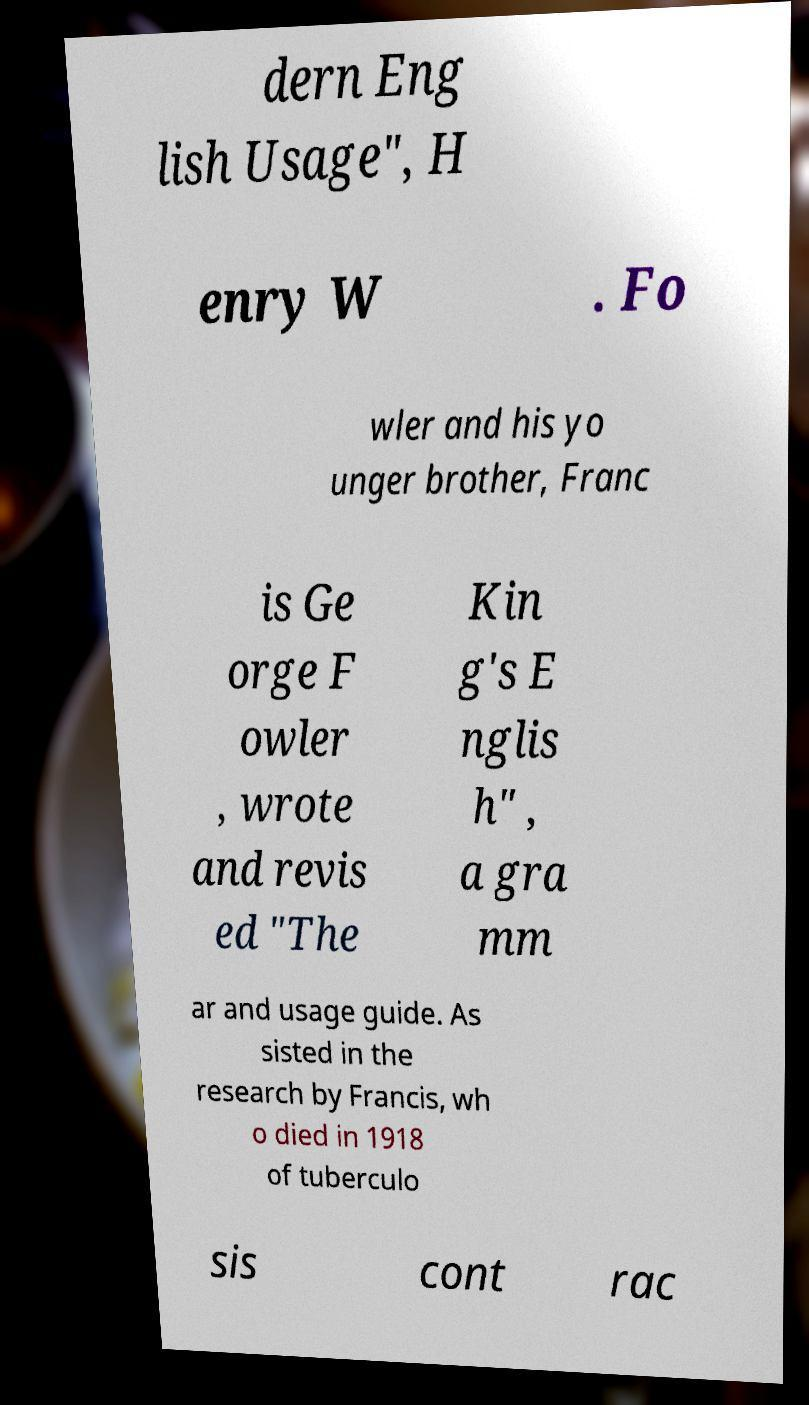For documentation purposes, I need the text within this image transcribed. Could you provide that? dern Eng lish Usage", H enry W . Fo wler and his yo unger brother, Franc is Ge orge F owler , wrote and revis ed "The Kin g's E nglis h" , a gra mm ar and usage guide. As sisted in the research by Francis, wh o died in 1918 of tuberculo sis cont rac 